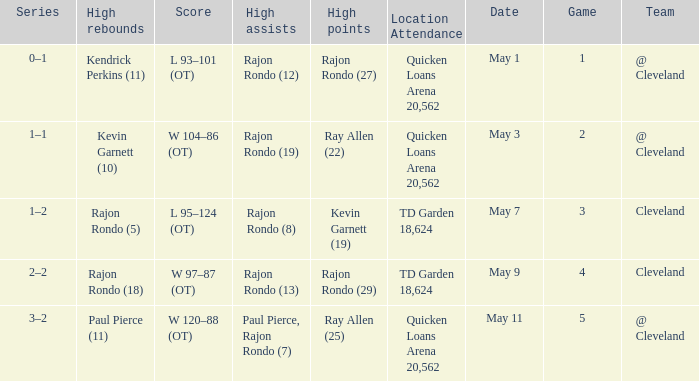Where does the team play May 3? @ Cleveland. 